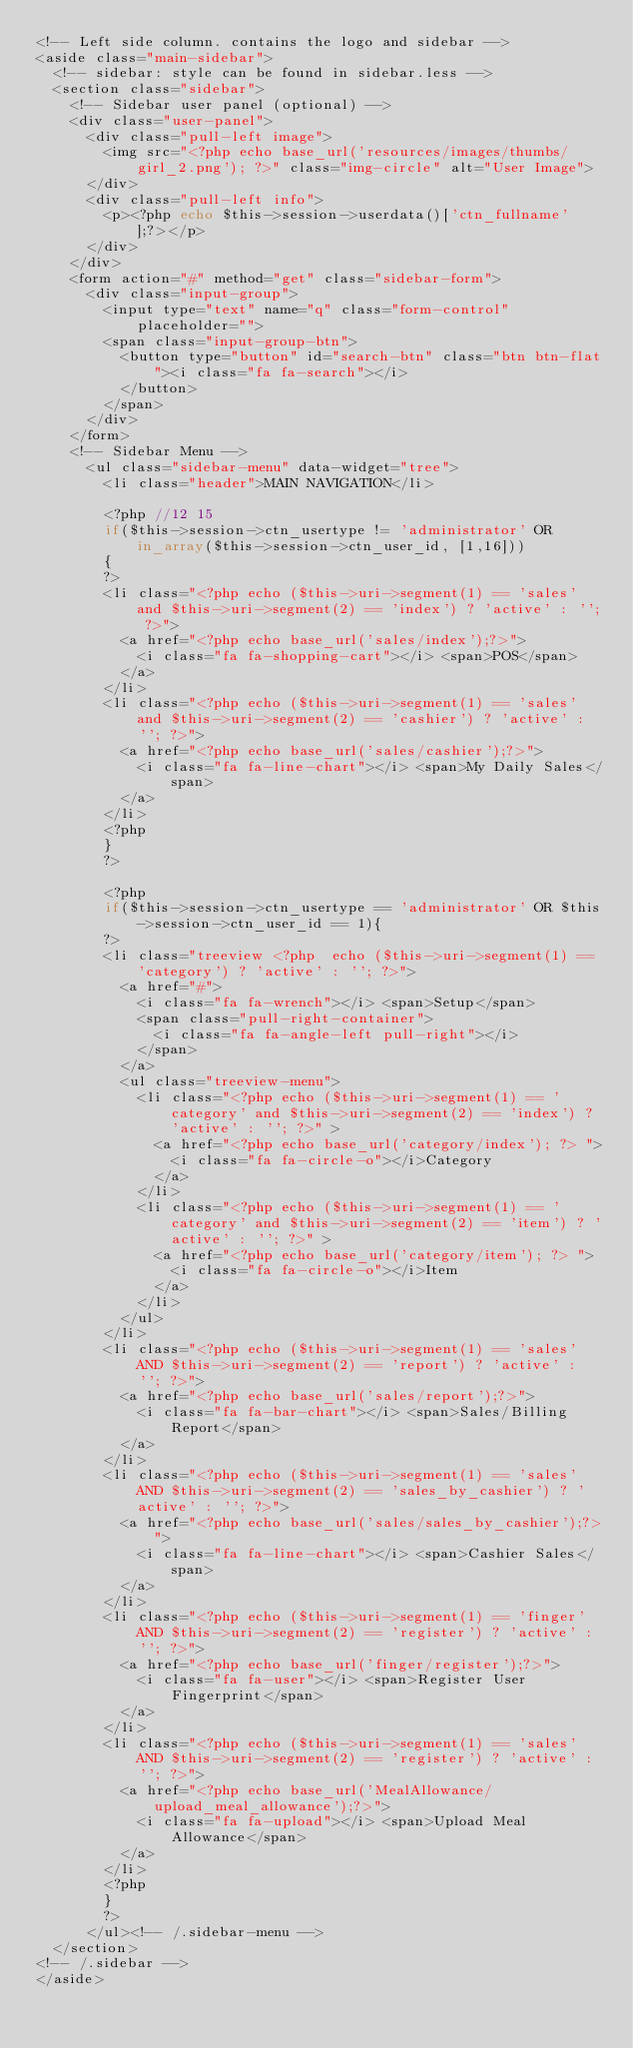Convert code to text. <code><loc_0><loc_0><loc_500><loc_500><_PHP_><!-- Left side column. contains the logo and sidebar -->
<aside class="main-sidebar">
	<!-- sidebar: style can be found in sidebar.less -->
	<section class="sidebar">
		<!-- Sidebar user panel (optional) -->
		<div class="user-panel">
			<div class="pull-left image">
				<img src="<?php echo base_url('resources/images/thumbs/girl_2.png'); ?>" class="img-circle" alt="User Image">
			</div>
			<div class="pull-left info">
				<p><?php echo $this->session->userdata()['ctn_fullname'];?></p>
			</div>
		</div>
		<form action="#" method="get" class="sidebar-form">
			<div class="input-group">
				<input type="text" name="q" class="form-control" placeholder="">
				<span class="input-group-btn">
					<button type="button" id="search-btn" class="btn btn-flat"><i class="fa fa-search"></i>
					</button>
				</span>
			</div>
		</form>
		<!-- Sidebar Menu -->
			<ul class="sidebar-menu" data-widget="tree">
				<li class="header">MAIN NAVIGATION</li>
				
				<?php //12 15
				if($this->session->ctn_usertype != 'administrator' OR in_array($this->session->ctn_user_id, [1,16]))
				{
				?>
				<li class="<?php echo ($this->uri->segment(1) == 'sales' and $this->uri->segment(2) == 'index') ? 'active' : ''; ?>">
					<a href="<?php echo base_url('sales/index');?>">
						<i class="fa fa-shopping-cart"></i> <span>POS</span>
					</a>
				</li>
				<li class="<?php echo ($this->uri->segment(1) == 'sales' and $this->uri->segment(2) == 'cashier') ? 'active' : ''; ?>">
					<a href="<?php echo base_url('sales/cashier');?>">
						<i class="fa fa-line-chart"></i> <span>My Daily Sales</span>
					</a>
				</li>
				<?php 
				}
				?>

				<?php 
				if($this->session->ctn_usertype == 'administrator' OR $this->session->ctn_user_id == 1){
				?>
				<li class="treeview <?php  echo ($this->uri->segment(1) == 'category') ? 'active' : ''; ?>">
					<a href="#">
						<i class="fa fa-wrench"></i> <span>Setup</span>
						<span class="pull-right-container">
							<i class="fa fa-angle-left pull-right"></i>
						</span>
					</a>
					<ul class="treeview-menu">
						<li class="<?php echo ($this->uri->segment(1) == 'category' and $this->uri->segment(2) == 'index') ? 'active' : ''; ?>" >
							<a href="<?php echo base_url('category/index'); ?> ">
								<i class="fa fa-circle-o"></i>Category
							</a>
						</li>
						<li class="<?php echo ($this->uri->segment(1) == 'category' and $this->uri->segment(2) == 'item') ? 'active' : ''; ?>" >
							<a href="<?php echo base_url('category/item'); ?> ">
								<i class="fa fa-circle-o"></i>Item
							</a>
						</li>
					</ul>
				</li>
				<li class="<?php echo ($this->uri->segment(1) == 'sales' AND $this->uri->segment(2) == 'report') ? 'active' : ''; ?>">
					<a href="<?php echo base_url('sales/report');?>">
						<i class="fa fa-bar-chart"></i> <span>Sales/Billing Report</span>
					</a>
				</li>
				<li class="<?php echo ($this->uri->segment(1) == 'sales' AND $this->uri->segment(2) == 'sales_by_cashier') ? 'active' : ''; ?>">
					<a href="<?php echo base_url('sales/sales_by_cashier');?>">
						<i class="fa fa-line-chart"></i> <span>Cashier Sales</span>
					</a>
				</li>
				<li class="<?php echo ($this->uri->segment(1) == 'finger' AND $this->uri->segment(2) == 'register') ? 'active' : ''; ?>">
					<a href="<?php echo base_url('finger/register');?>">
						<i class="fa fa-user"></i> <span>Register User Fingerprint</span>
					</a>
				</li>
				<li class="<?php echo ($this->uri->segment(1) == 'sales' AND $this->uri->segment(2) == 'register') ? 'active' : ''; ?>">
					<a href="<?php echo base_url('MealAllowance/upload_meal_allowance');?>">
						<i class="fa fa-upload"></i> <span>Upload Meal Allowance</span>
					</a>
				</li>
				<?php 
				}
				?>
			</ul><!-- /.sidebar-menu -->
	</section>
<!-- /.sidebar -->
</aside>

</code> 